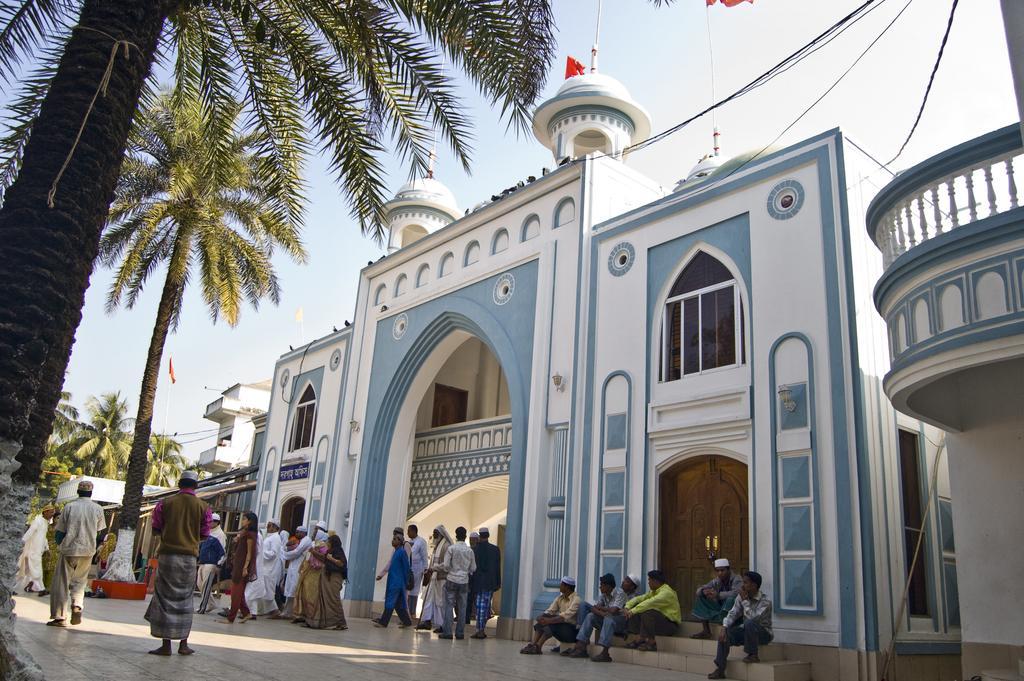In one or two sentences, can you explain what this image depicts? In this image we can see a few people and buildings, there are some windows, doors, flags, wires and trees, in the background we can see the sky. 